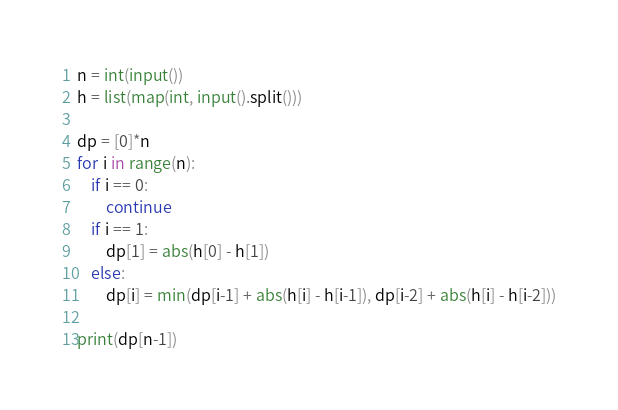Convert code to text. <code><loc_0><loc_0><loc_500><loc_500><_Python_>n = int(input())
h = list(map(int, input().split()))

dp = [0]*n
for i in range(n):
    if i == 0:
        continue
    if i == 1:
        dp[1] = abs(h[0] - h[1])
    else:
        dp[i] = min(dp[i-1] + abs(h[i] - h[i-1]), dp[i-2] + abs(h[i] - h[i-2]))
        
print(dp[n-1])</code> 